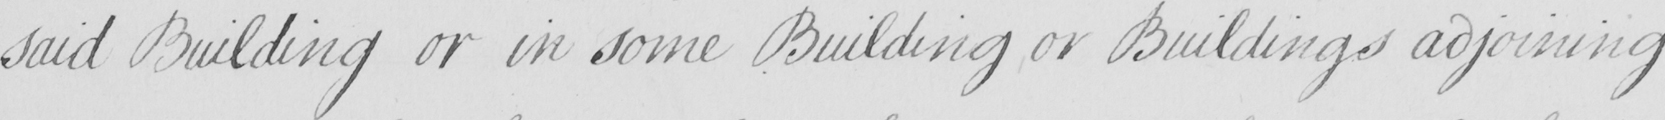Please transcribe the handwritten text in this image. said Building or in some Building or Buildings adjoining 